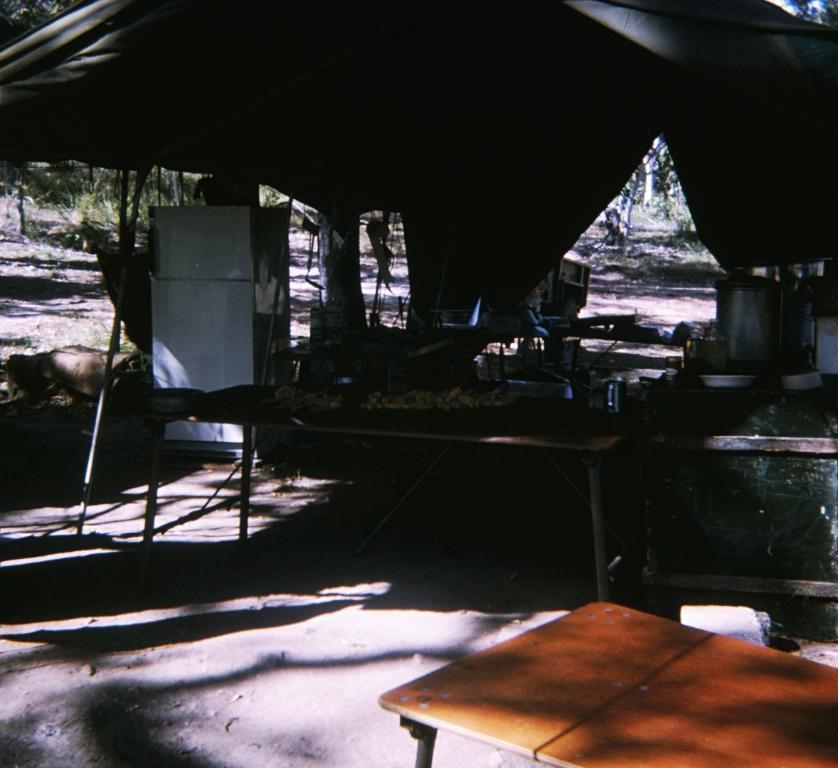Can you describe this image briefly? In this image we can see a tent. Under the tent we can see group of objects and there are few objects on the tables. Behind the rent we can see the trees. In the bottom right we can see a table. 